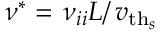Convert formula to latex. <formula><loc_0><loc_0><loc_500><loc_500>\nu ^ { * } = \nu _ { i i } L \right / { v _ { t h _ { s } } }</formula> 